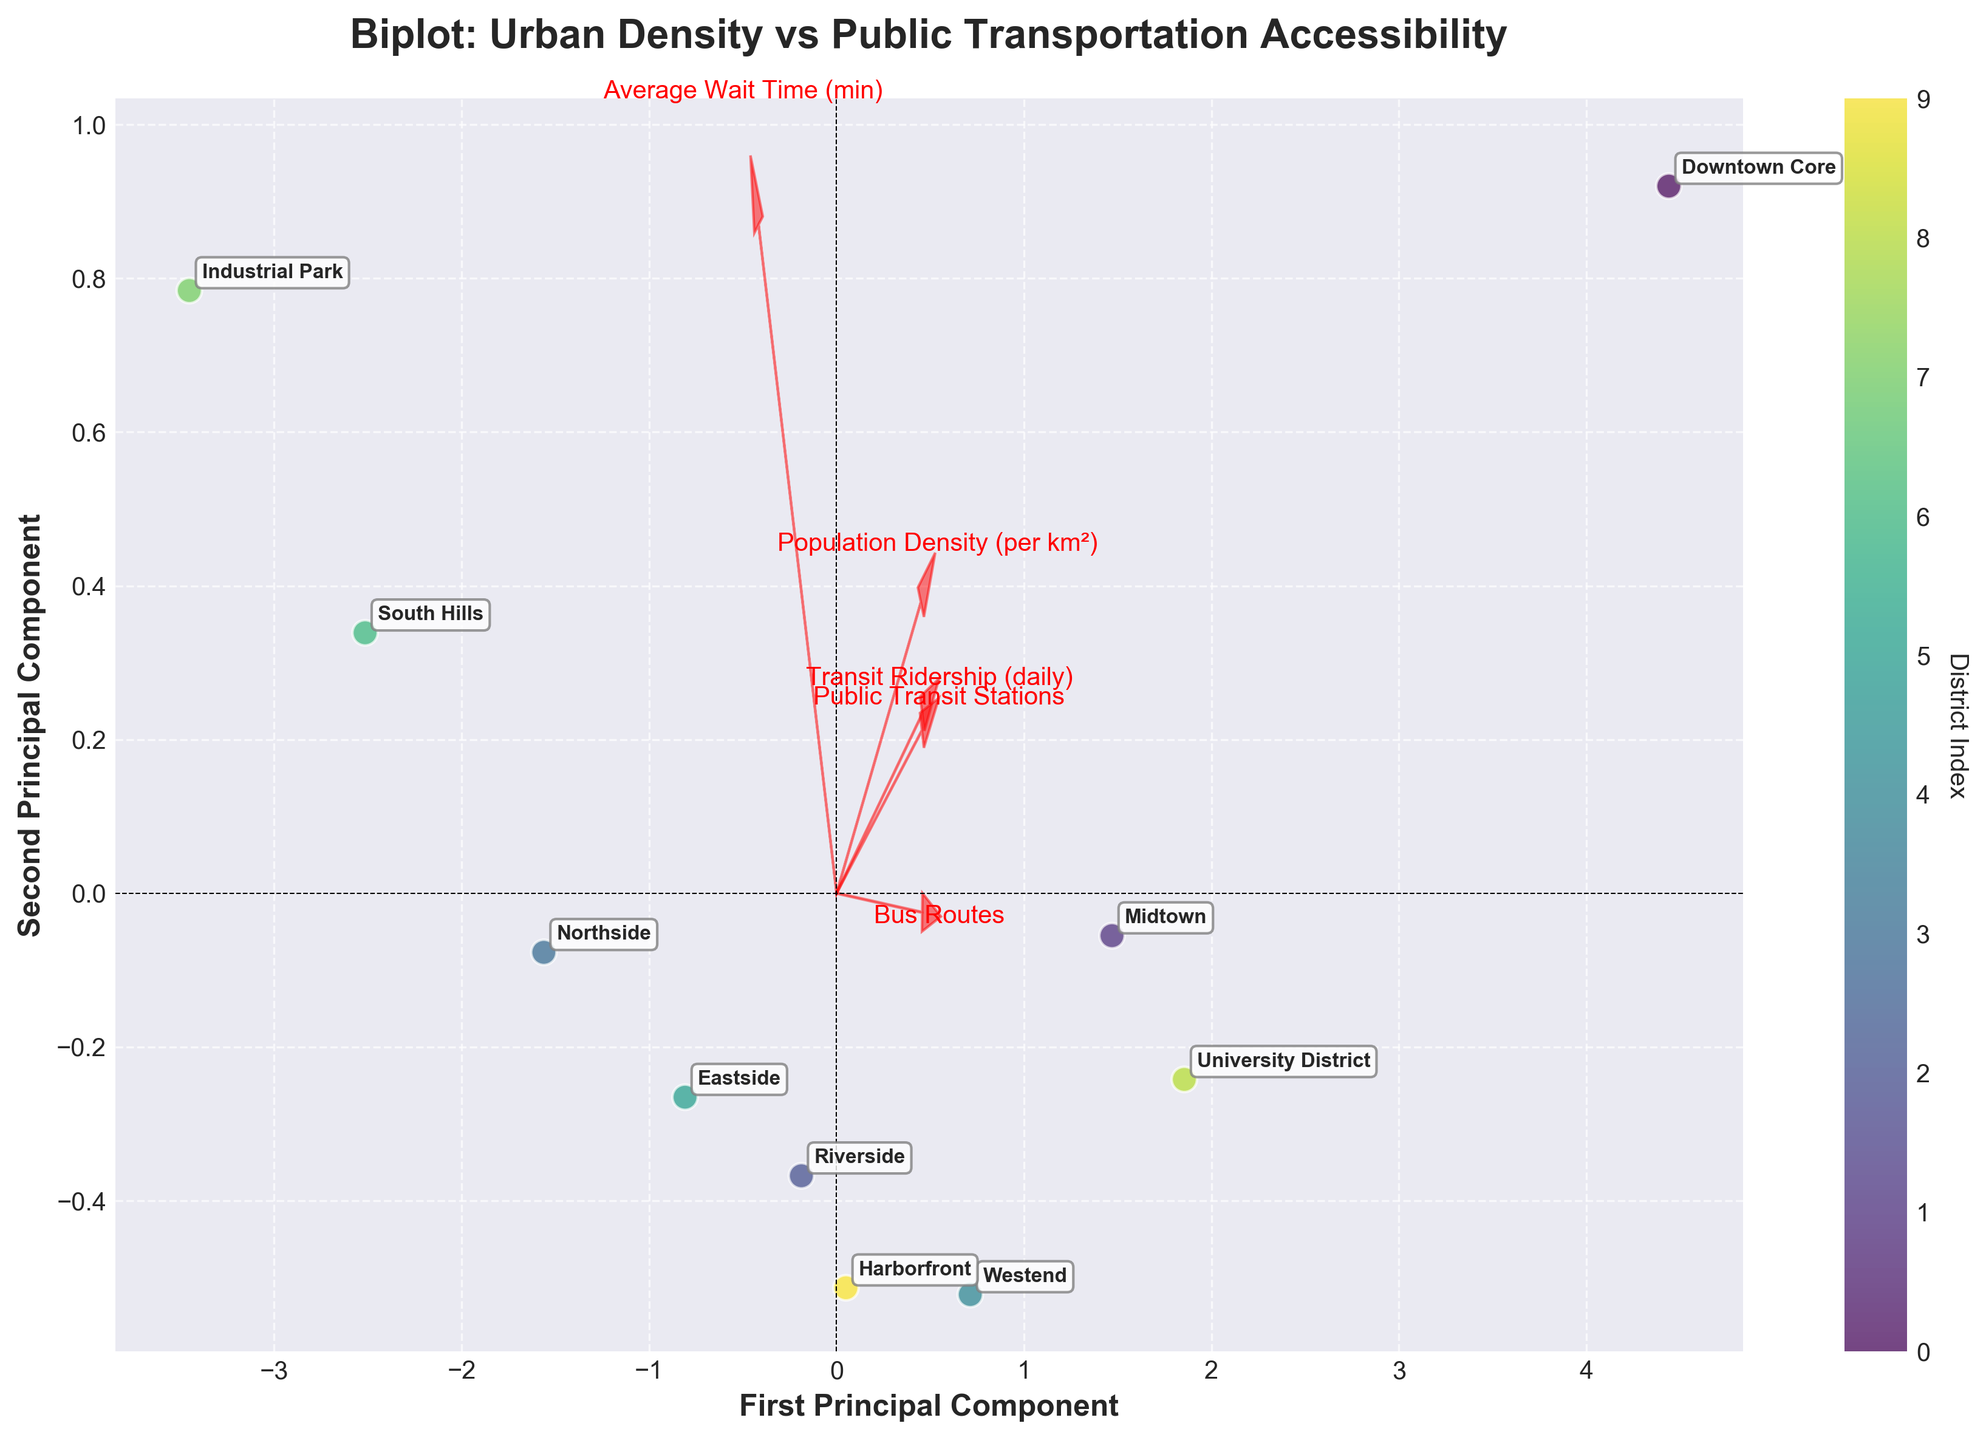What is the title of the plot? The title of the plot is located at the top center of the figure. It gives an overview of what the figure is about.
Answer: Biplot: Urban Density vs Public Transportation Accessibility How many districts are represented in the plot? To find out the number of districts, count the unique labels annotated on the data points.
Answer: 10 Which district is closest to the origin of the plot? Identify the point with the shortest distance to the center, where both principal component axes intersect.
Answer: South Hills Which district has the highest value along the first principal component? Look for the data point that is farthest to the right along the x-axis (First Principal Component).
Answer: Downtown Core Which feature vectors (red arrows) have a positive correlation along both principal components? Positive correlation along both components means the arrows should point towards the top-right direction.
Answer: Public Transit Stations, Bus Routes, Transit Ridership (daily) Which districts have similar profiles in the plot based on their positions? Districts that are close to each other in the plot have similar profiles. Identify groups of data points that are clustered together.
Answer: Midtown and University District If you increase the size of 'Population Density (per km²)', what impact would you expect on 'Transit Ridership (daily)' based on their representation in the plot? 'Population Density (per km²)' is positively correlated with 'Transit Ridership (daily)' as indicated by their feature vectors pointing in roughly the same direction. Increasing one is likely to increase the other.
Answer: Increase How does 'Average Wait Time (min)' compare between the 'Downtown Core' and 'South Hills'? Identify and compare the positions of 'Downtown Core' and 'South Hills' along the arrow representing 'Average Wait Time (min)', which is pointing negatively along the first principal component.
Answer: 'Downtown Core' has a lower average wait time than 'South Hills' Which feature contributes most to the first principal component? The feature whose vector has the largest projection on the x-axis contributes the most to the first principal component.
Answer: Population Density (per km²) What does a negative value along the second principal component indicate about 'Public Transit Stations'? 'Public Transit Stations' is mainly aligned positively along the second principal component. A negative value along the second principal component suggests fewer transit stations.
Answer: Fewer transit stations 